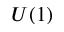<formula> <loc_0><loc_0><loc_500><loc_500>U ( 1 )</formula> 